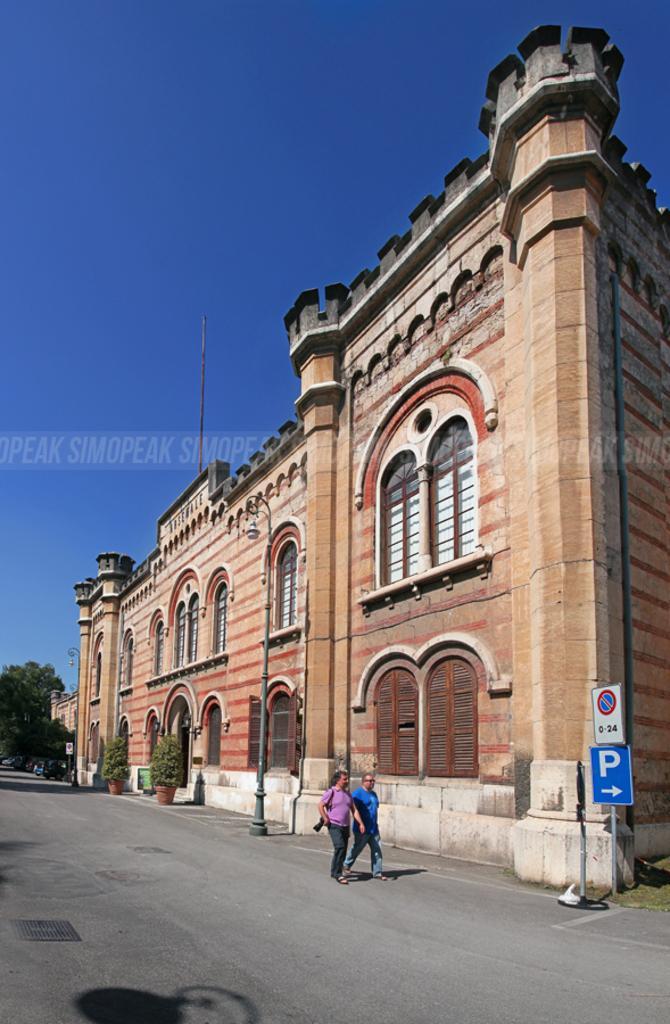Could you give a brief overview of what you see in this image? In this picture we can see a building on the right side, there are two persons walking on the road, we can see two plants, a pole and two boards on the right side, on the left side there is a tree, we can see the sky at the top of the picture, there is some text in the middle. 